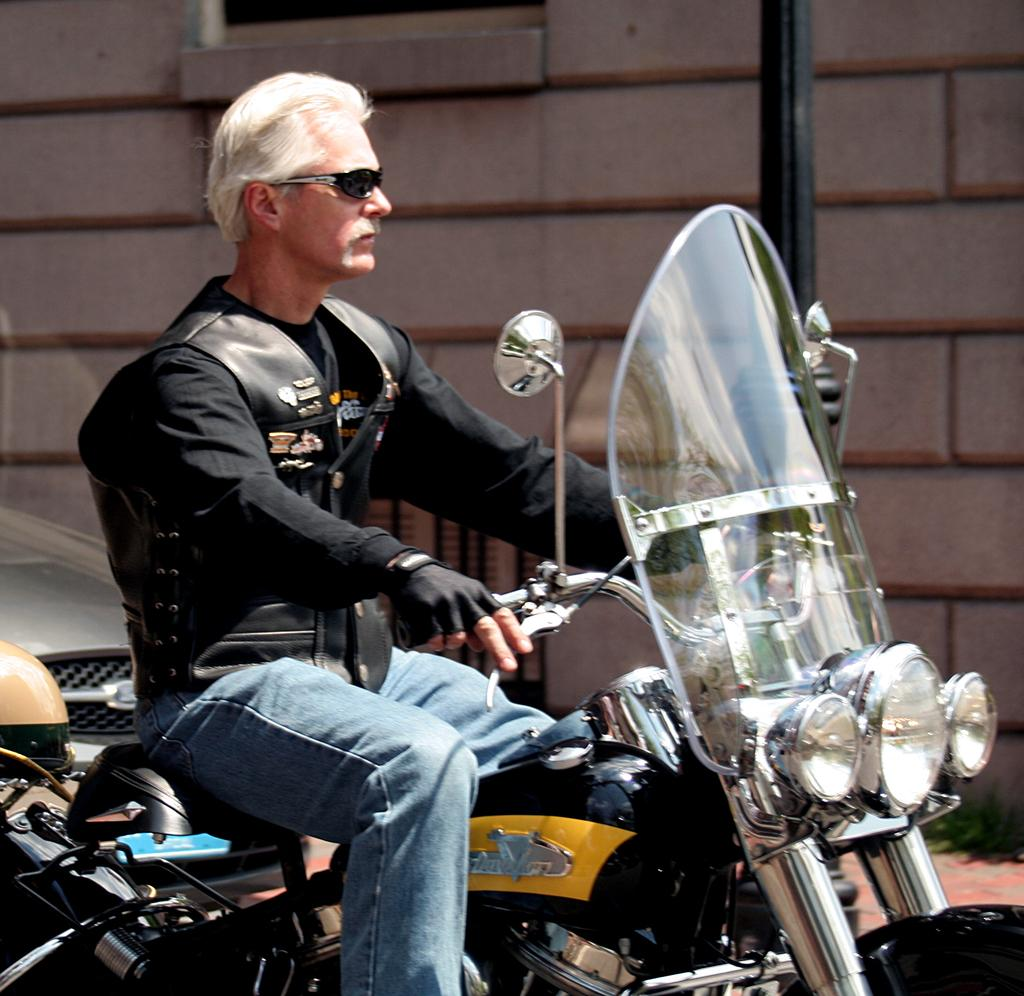What is the man in the image doing? The man is riding a motorcycle in the image. What is the man wearing while riding the motorcycle? The man is wearing glasses in the image. What can be seen in the background of the image? There is a wall, a pole, and a vehicle in the background of the image. What type of net is being used to catch fish in the image? There is no net or fishing activity present in the image. What kind of bait is the man using to attract fish in the image? There is no fishing or bait present in the image; the man is riding a motorcycle. 